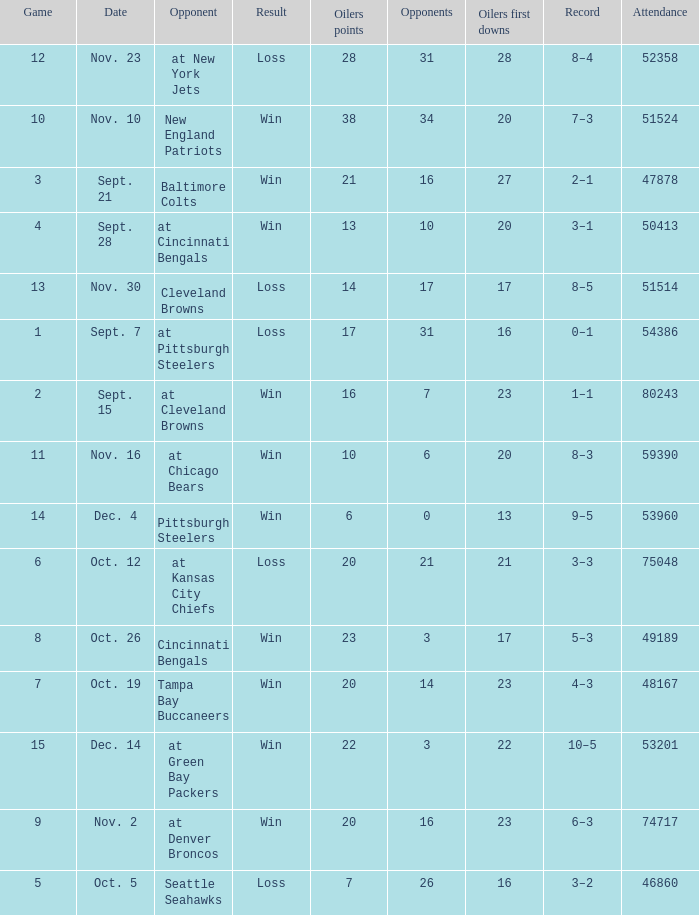What was the total opponents points for the game were the Oilers scored 21? 16.0. 